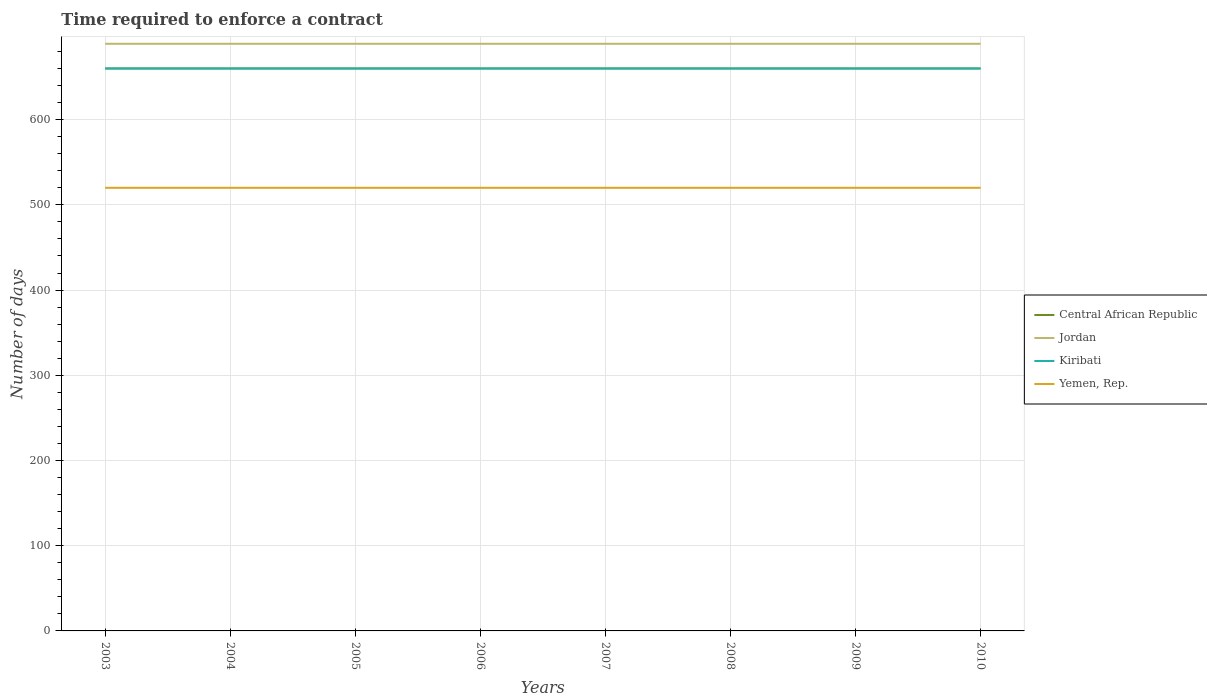Across all years, what is the maximum number of days required to enforce a contract in Kiribati?
Keep it short and to the point. 660. In which year was the number of days required to enforce a contract in Central African Republic maximum?
Provide a short and direct response. 2003. What is the total number of days required to enforce a contract in Yemen, Rep. in the graph?
Offer a terse response. 0. What is the difference between the highest and the lowest number of days required to enforce a contract in Yemen, Rep.?
Offer a terse response. 0. What is the difference between two consecutive major ticks on the Y-axis?
Offer a very short reply. 100. How many legend labels are there?
Your answer should be compact. 4. What is the title of the graph?
Your response must be concise. Time required to enforce a contract. What is the label or title of the X-axis?
Offer a very short reply. Years. What is the label or title of the Y-axis?
Provide a short and direct response. Number of days. What is the Number of days of Central African Republic in 2003?
Offer a terse response. 660. What is the Number of days of Jordan in 2003?
Make the answer very short. 689. What is the Number of days in Kiribati in 2003?
Your response must be concise. 660. What is the Number of days of Yemen, Rep. in 2003?
Provide a succinct answer. 520. What is the Number of days of Central African Republic in 2004?
Give a very brief answer. 660. What is the Number of days in Jordan in 2004?
Offer a terse response. 689. What is the Number of days in Kiribati in 2004?
Your answer should be compact. 660. What is the Number of days of Yemen, Rep. in 2004?
Keep it short and to the point. 520. What is the Number of days of Central African Republic in 2005?
Provide a succinct answer. 660. What is the Number of days in Jordan in 2005?
Provide a succinct answer. 689. What is the Number of days of Kiribati in 2005?
Provide a succinct answer. 660. What is the Number of days in Yemen, Rep. in 2005?
Your answer should be compact. 520. What is the Number of days in Central African Republic in 2006?
Keep it short and to the point. 660. What is the Number of days of Jordan in 2006?
Offer a terse response. 689. What is the Number of days of Kiribati in 2006?
Keep it short and to the point. 660. What is the Number of days of Yemen, Rep. in 2006?
Offer a very short reply. 520. What is the Number of days of Central African Republic in 2007?
Provide a short and direct response. 660. What is the Number of days in Jordan in 2007?
Provide a succinct answer. 689. What is the Number of days in Kiribati in 2007?
Your response must be concise. 660. What is the Number of days in Yemen, Rep. in 2007?
Give a very brief answer. 520. What is the Number of days of Central African Republic in 2008?
Ensure brevity in your answer.  660. What is the Number of days in Jordan in 2008?
Your answer should be very brief. 689. What is the Number of days in Kiribati in 2008?
Offer a very short reply. 660. What is the Number of days in Yemen, Rep. in 2008?
Provide a short and direct response. 520. What is the Number of days in Central African Republic in 2009?
Make the answer very short. 660. What is the Number of days of Jordan in 2009?
Offer a terse response. 689. What is the Number of days in Kiribati in 2009?
Keep it short and to the point. 660. What is the Number of days in Yemen, Rep. in 2009?
Your answer should be very brief. 520. What is the Number of days of Central African Republic in 2010?
Make the answer very short. 660. What is the Number of days of Jordan in 2010?
Keep it short and to the point. 689. What is the Number of days in Kiribati in 2010?
Provide a short and direct response. 660. What is the Number of days in Yemen, Rep. in 2010?
Ensure brevity in your answer.  520. Across all years, what is the maximum Number of days in Central African Republic?
Your response must be concise. 660. Across all years, what is the maximum Number of days of Jordan?
Ensure brevity in your answer.  689. Across all years, what is the maximum Number of days of Kiribati?
Provide a short and direct response. 660. Across all years, what is the maximum Number of days of Yemen, Rep.?
Your answer should be compact. 520. Across all years, what is the minimum Number of days in Central African Republic?
Keep it short and to the point. 660. Across all years, what is the minimum Number of days of Jordan?
Give a very brief answer. 689. Across all years, what is the minimum Number of days of Kiribati?
Your answer should be compact. 660. Across all years, what is the minimum Number of days in Yemen, Rep.?
Provide a succinct answer. 520. What is the total Number of days of Central African Republic in the graph?
Your answer should be very brief. 5280. What is the total Number of days in Jordan in the graph?
Your response must be concise. 5512. What is the total Number of days in Kiribati in the graph?
Ensure brevity in your answer.  5280. What is the total Number of days in Yemen, Rep. in the graph?
Offer a very short reply. 4160. What is the difference between the Number of days of Central African Republic in 2003 and that in 2004?
Give a very brief answer. 0. What is the difference between the Number of days in Jordan in 2003 and that in 2004?
Your answer should be very brief. 0. What is the difference between the Number of days in Kiribati in 2003 and that in 2004?
Keep it short and to the point. 0. What is the difference between the Number of days in Jordan in 2003 and that in 2005?
Offer a very short reply. 0. What is the difference between the Number of days in Central African Republic in 2003 and that in 2006?
Keep it short and to the point. 0. What is the difference between the Number of days in Kiribati in 2003 and that in 2006?
Your answer should be compact. 0. What is the difference between the Number of days in Jordan in 2003 and that in 2007?
Your answer should be compact. 0. What is the difference between the Number of days of Central African Republic in 2003 and that in 2008?
Ensure brevity in your answer.  0. What is the difference between the Number of days of Kiribati in 2003 and that in 2008?
Your response must be concise. 0. What is the difference between the Number of days in Yemen, Rep. in 2003 and that in 2008?
Provide a short and direct response. 0. What is the difference between the Number of days in Central African Republic in 2003 and that in 2009?
Provide a succinct answer. 0. What is the difference between the Number of days in Jordan in 2003 and that in 2009?
Provide a succinct answer. 0. What is the difference between the Number of days in Central African Republic in 2003 and that in 2010?
Ensure brevity in your answer.  0. What is the difference between the Number of days of Jordan in 2003 and that in 2010?
Provide a short and direct response. 0. What is the difference between the Number of days in Central African Republic in 2004 and that in 2005?
Provide a short and direct response. 0. What is the difference between the Number of days in Yemen, Rep. in 2004 and that in 2005?
Provide a short and direct response. 0. What is the difference between the Number of days of Kiribati in 2004 and that in 2007?
Offer a terse response. 0. What is the difference between the Number of days in Central African Republic in 2004 and that in 2008?
Provide a succinct answer. 0. What is the difference between the Number of days of Jordan in 2004 and that in 2008?
Keep it short and to the point. 0. What is the difference between the Number of days of Central African Republic in 2004 and that in 2009?
Offer a very short reply. 0. What is the difference between the Number of days of Jordan in 2004 and that in 2009?
Provide a short and direct response. 0. What is the difference between the Number of days of Kiribati in 2004 and that in 2009?
Ensure brevity in your answer.  0. What is the difference between the Number of days of Central African Republic in 2005 and that in 2006?
Give a very brief answer. 0. What is the difference between the Number of days of Jordan in 2005 and that in 2006?
Offer a very short reply. 0. What is the difference between the Number of days of Yemen, Rep. in 2005 and that in 2006?
Your response must be concise. 0. What is the difference between the Number of days in Jordan in 2005 and that in 2007?
Ensure brevity in your answer.  0. What is the difference between the Number of days in Kiribati in 2005 and that in 2008?
Offer a terse response. 0. What is the difference between the Number of days of Jordan in 2005 and that in 2009?
Offer a very short reply. 0. What is the difference between the Number of days in Kiribati in 2005 and that in 2009?
Ensure brevity in your answer.  0. What is the difference between the Number of days of Yemen, Rep. in 2005 and that in 2009?
Give a very brief answer. 0. What is the difference between the Number of days of Jordan in 2005 and that in 2010?
Your answer should be very brief. 0. What is the difference between the Number of days of Yemen, Rep. in 2006 and that in 2008?
Provide a succinct answer. 0. What is the difference between the Number of days in Central African Republic in 2006 and that in 2009?
Keep it short and to the point. 0. What is the difference between the Number of days in Jordan in 2006 and that in 2009?
Make the answer very short. 0. What is the difference between the Number of days in Kiribati in 2006 and that in 2009?
Give a very brief answer. 0. What is the difference between the Number of days of Jordan in 2006 and that in 2010?
Your answer should be compact. 0. What is the difference between the Number of days of Yemen, Rep. in 2006 and that in 2010?
Your answer should be very brief. 0. What is the difference between the Number of days of Central African Republic in 2007 and that in 2008?
Offer a terse response. 0. What is the difference between the Number of days of Jordan in 2007 and that in 2008?
Keep it short and to the point. 0. What is the difference between the Number of days in Jordan in 2007 and that in 2009?
Provide a short and direct response. 0. What is the difference between the Number of days of Kiribati in 2007 and that in 2009?
Keep it short and to the point. 0. What is the difference between the Number of days in Yemen, Rep. in 2007 and that in 2010?
Your answer should be compact. 0. What is the difference between the Number of days of Jordan in 2008 and that in 2009?
Provide a short and direct response. 0. What is the difference between the Number of days in Kiribati in 2008 and that in 2009?
Ensure brevity in your answer.  0. What is the difference between the Number of days in Yemen, Rep. in 2008 and that in 2010?
Keep it short and to the point. 0. What is the difference between the Number of days of Central African Republic in 2009 and that in 2010?
Provide a succinct answer. 0. What is the difference between the Number of days in Jordan in 2009 and that in 2010?
Provide a short and direct response. 0. What is the difference between the Number of days in Kiribati in 2009 and that in 2010?
Your answer should be compact. 0. What is the difference between the Number of days in Central African Republic in 2003 and the Number of days in Jordan in 2004?
Provide a short and direct response. -29. What is the difference between the Number of days in Central African Republic in 2003 and the Number of days in Yemen, Rep. in 2004?
Ensure brevity in your answer.  140. What is the difference between the Number of days of Jordan in 2003 and the Number of days of Kiribati in 2004?
Ensure brevity in your answer.  29. What is the difference between the Number of days of Jordan in 2003 and the Number of days of Yemen, Rep. in 2004?
Your answer should be very brief. 169. What is the difference between the Number of days in Kiribati in 2003 and the Number of days in Yemen, Rep. in 2004?
Keep it short and to the point. 140. What is the difference between the Number of days of Central African Republic in 2003 and the Number of days of Yemen, Rep. in 2005?
Provide a short and direct response. 140. What is the difference between the Number of days of Jordan in 2003 and the Number of days of Kiribati in 2005?
Provide a succinct answer. 29. What is the difference between the Number of days of Jordan in 2003 and the Number of days of Yemen, Rep. in 2005?
Offer a very short reply. 169. What is the difference between the Number of days in Kiribati in 2003 and the Number of days in Yemen, Rep. in 2005?
Offer a terse response. 140. What is the difference between the Number of days in Central African Republic in 2003 and the Number of days in Jordan in 2006?
Provide a succinct answer. -29. What is the difference between the Number of days in Central African Republic in 2003 and the Number of days in Yemen, Rep. in 2006?
Give a very brief answer. 140. What is the difference between the Number of days in Jordan in 2003 and the Number of days in Yemen, Rep. in 2006?
Keep it short and to the point. 169. What is the difference between the Number of days of Kiribati in 2003 and the Number of days of Yemen, Rep. in 2006?
Provide a short and direct response. 140. What is the difference between the Number of days of Central African Republic in 2003 and the Number of days of Kiribati in 2007?
Provide a short and direct response. 0. What is the difference between the Number of days of Central African Republic in 2003 and the Number of days of Yemen, Rep. in 2007?
Make the answer very short. 140. What is the difference between the Number of days in Jordan in 2003 and the Number of days in Kiribati in 2007?
Give a very brief answer. 29. What is the difference between the Number of days of Jordan in 2003 and the Number of days of Yemen, Rep. in 2007?
Provide a succinct answer. 169. What is the difference between the Number of days in Kiribati in 2003 and the Number of days in Yemen, Rep. in 2007?
Your answer should be very brief. 140. What is the difference between the Number of days in Central African Republic in 2003 and the Number of days in Yemen, Rep. in 2008?
Your response must be concise. 140. What is the difference between the Number of days of Jordan in 2003 and the Number of days of Kiribati in 2008?
Provide a succinct answer. 29. What is the difference between the Number of days in Jordan in 2003 and the Number of days in Yemen, Rep. in 2008?
Your answer should be very brief. 169. What is the difference between the Number of days of Kiribati in 2003 and the Number of days of Yemen, Rep. in 2008?
Make the answer very short. 140. What is the difference between the Number of days of Central African Republic in 2003 and the Number of days of Jordan in 2009?
Keep it short and to the point. -29. What is the difference between the Number of days of Central African Republic in 2003 and the Number of days of Kiribati in 2009?
Your response must be concise. 0. What is the difference between the Number of days of Central African Republic in 2003 and the Number of days of Yemen, Rep. in 2009?
Offer a terse response. 140. What is the difference between the Number of days of Jordan in 2003 and the Number of days of Yemen, Rep. in 2009?
Provide a short and direct response. 169. What is the difference between the Number of days of Kiribati in 2003 and the Number of days of Yemen, Rep. in 2009?
Provide a short and direct response. 140. What is the difference between the Number of days of Central African Republic in 2003 and the Number of days of Yemen, Rep. in 2010?
Provide a succinct answer. 140. What is the difference between the Number of days of Jordan in 2003 and the Number of days of Yemen, Rep. in 2010?
Your answer should be compact. 169. What is the difference between the Number of days of Kiribati in 2003 and the Number of days of Yemen, Rep. in 2010?
Offer a terse response. 140. What is the difference between the Number of days in Central African Republic in 2004 and the Number of days in Yemen, Rep. in 2005?
Offer a terse response. 140. What is the difference between the Number of days of Jordan in 2004 and the Number of days of Kiribati in 2005?
Keep it short and to the point. 29. What is the difference between the Number of days in Jordan in 2004 and the Number of days in Yemen, Rep. in 2005?
Offer a very short reply. 169. What is the difference between the Number of days of Kiribati in 2004 and the Number of days of Yemen, Rep. in 2005?
Offer a terse response. 140. What is the difference between the Number of days of Central African Republic in 2004 and the Number of days of Yemen, Rep. in 2006?
Your answer should be very brief. 140. What is the difference between the Number of days of Jordan in 2004 and the Number of days of Yemen, Rep. in 2006?
Your answer should be very brief. 169. What is the difference between the Number of days of Kiribati in 2004 and the Number of days of Yemen, Rep. in 2006?
Give a very brief answer. 140. What is the difference between the Number of days in Central African Republic in 2004 and the Number of days in Yemen, Rep. in 2007?
Your answer should be very brief. 140. What is the difference between the Number of days in Jordan in 2004 and the Number of days in Kiribati in 2007?
Your response must be concise. 29. What is the difference between the Number of days in Jordan in 2004 and the Number of days in Yemen, Rep. in 2007?
Keep it short and to the point. 169. What is the difference between the Number of days of Kiribati in 2004 and the Number of days of Yemen, Rep. in 2007?
Your answer should be very brief. 140. What is the difference between the Number of days of Central African Republic in 2004 and the Number of days of Yemen, Rep. in 2008?
Provide a short and direct response. 140. What is the difference between the Number of days in Jordan in 2004 and the Number of days in Yemen, Rep. in 2008?
Ensure brevity in your answer.  169. What is the difference between the Number of days in Kiribati in 2004 and the Number of days in Yemen, Rep. in 2008?
Offer a very short reply. 140. What is the difference between the Number of days of Central African Republic in 2004 and the Number of days of Jordan in 2009?
Your response must be concise. -29. What is the difference between the Number of days of Central African Republic in 2004 and the Number of days of Yemen, Rep. in 2009?
Ensure brevity in your answer.  140. What is the difference between the Number of days of Jordan in 2004 and the Number of days of Kiribati in 2009?
Provide a succinct answer. 29. What is the difference between the Number of days in Jordan in 2004 and the Number of days in Yemen, Rep. in 2009?
Make the answer very short. 169. What is the difference between the Number of days in Kiribati in 2004 and the Number of days in Yemen, Rep. in 2009?
Make the answer very short. 140. What is the difference between the Number of days in Central African Republic in 2004 and the Number of days in Yemen, Rep. in 2010?
Provide a short and direct response. 140. What is the difference between the Number of days in Jordan in 2004 and the Number of days in Yemen, Rep. in 2010?
Your answer should be very brief. 169. What is the difference between the Number of days in Kiribati in 2004 and the Number of days in Yemen, Rep. in 2010?
Your answer should be compact. 140. What is the difference between the Number of days of Central African Republic in 2005 and the Number of days of Yemen, Rep. in 2006?
Your response must be concise. 140. What is the difference between the Number of days of Jordan in 2005 and the Number of days of Yemen, Rep. in 2006?
Provide a short and direct response. 169. What is the difference between the Number of days in Kiribati in 2005 and the Number of days in Yemen, Rep. in 2006?
Your answer should be very brief. 140. What is the difference between the Number of days of Central African Republic in 2005 and the Number of days of Kiribati in 2007?
Your answer should be very brief. 0. What is the difference between the Number of days of Central African Republic in 2005 and the Number of days of Yemen, Rep. in 2007?
Keep it short and to the point. 140. What is the difference between the Number of days of Jordan in 2005 and the Number of days of Yemen, Rep. in 2007?
Your response must be concise. 169. What is the difference between the Number of days in Kiribati in 2005 and the Number of days in Yemen, Rep. in 2007?
Your answer should be very brief. 140. What is the difference between the Number of days of Central African Republic in 2005 and the Number of days of Kiribati in 2008?
Your response must be concise. 0. What is the difference between the Number of days in Central African Republic in 2005 and the Number of days in Yemen, Rep. in 2008?
Your response must be concise. 140. What is the difference between the Number of days in Jordan in 2005 and the Number of days in Yemen, Rep. in 2008?
Your response must be concise. 169. What is the difference between the Number of days in Kiribati in 2005 and the Number of days in Yemen, Rep. in 2008?
Keep it short and to the point. 140. What is the difference between the Number of days of Central African Republic in 2005 and the Number of days of Jordan in 2009?
Your answer should be very brief. -29. What is the difference between the Number of days of Central African Republic in 2005 and the Number of days of Kiribati in 2009?
Your answer should be very brief. 0. What is the difference between the Number of days of Central African Republic in 2005 and the Number of days of Yemen, Rep. in 2009?
Give a very brief answer. 140. What is the difference between the Number of days of Jordan in 2005 and the Number of days of Kiribati in 2009?
Provide a succinct answer. 29. What is the difference between the Number of days of Jordan in 2005 and the Number of days of Yemen, Rep. in 2009?
Keep it short and to the point. 169. What is the difference between the Number of days in Kiribati in 2005 and the Number of days in Yemen, Rep. in 2009?
Your answer should be very brief. 140. What is the difference between the Number of days in Central African Republic in 2005 and the Number of days in Kiribati in 2010?
Your answer should be compact. 0. What is the difference between the Number of days of Central African Republic in 2005 and the Number of days of Yemen, Rep. in 2010?
Keep it short and to the point. 140. What is the difference between the Number of days in Jordan in 2005 and the Number of days in Yemen, Rep. in 2010?
Offer a very short reply. 169. What is the difference between the Number of days in Kiribati in 2005 and the Number of days in Yemen, Rep. in 2010?
Give a very brief answer. 140. What is the difference between the Number of days of Central African Republic in 2006 and the Number of days of Jordan in 2007?
Provide a succinct answer. -29. What is the difference between the Number of days of Central African Republic in 2006 and the Number of days of Yemen, Rep. in 2007?
Provide a short and direct response. 140. What is the difference between the Number of days of Jordan in 2006 and the Number of days of Kiribati in 2007?
Offer a very short reply. 29. What is the difference between the Number of days in Jordan in 2006 and the Number of days in Yemen, Rep. in 2007?
Your answer should be very brief. 169. What is the difference between the Number of days in Kiribati in 2006 and the Number of days in Yemen, Rep. in 2007?
Your answer should be compact. 140. What is the difference between the Number of days of Central African Republic in 2006 and the Number of days of Yemen, Rep. in 2008?
Your answer should be compact. 140. What is the difference between the Number of days of Jordan in 2006 and the Number of days of Yemen, Rep. in 2008?
Your answer should be compact. 169. What is the difference between the Number of days of Kiribati in 2006 and the Number of days of Yemen, Rep. in 2008?
Offer a very short reply. 140. What is the difference between the Number of days of Central African Republic in 2006 and the Number of days of Yemen, Rep. in 2009?
Offer a terse response. 140. What is the difference between the Number of days in Jordan in 2006 and the Number of days in Kiribati in 2009?
Give a very brief answer. 29. What is the difference between the Number of days in Jordan in 2006 and the Number of days in Yemen, Rep. in 2009?
Offer a terse response. 169. What is the difference between the Number of days in Kiribati in 2006 and the Number of days in Yemen, Rep. in 2009?
Offer a terse response. 140. What is the difference between the Number of days in Central African Republic in 2006 and the Number of days in Jordan in 2010?
Provide a succinct answer. -29. What is the difference between the Number of days in Central African Republic in 2006 and the Number of days in Kiribati in 2010?
Your answer should be compact. 0. What is the difference between the Number of days in Central African Republic in 2006 and the Number of days in Yemen, Rep. in 2010?
Ensure brevity in your answer.  140. What is the difference between the Number of days in Jordan in 2006 and the Number of days in Yemen, Rep. in 2010?
Offer a terse response. 169. What is the difference between the Number of days of Kiribati in 2006 and the Number of days of Yemen, Rep. in 2010?
Make the answer very short. 140. What is the difference between the Number of days in Central African Republic in 2007 and the Number of days in Jordan in 2008?
Your response must be concise. -29. What is the difference between the Number of days of Central African Republic in 2007 and the Number of days of Yemen, Rep. in 2008?
Offer a very short reply. 140. What is the difference between the Number of days of Jordan in 2007 and the Number of days of Kiribati in 2008?
Provide a succinct answer. 29. What is the difference between the Number of days of Jordan in 2007 and the Number of days of Yemen, Rep. in 2008?
Provide a short and direct response. 169. What is the difference between the Number of days in Kiribati in 2007 and the Number of days in Yemen, Rep. in 2008?
Provide a short and direct response. 140. What is the difference between the Number of days of Central African Republic in 2007 and the Number of days of Jordan in 2009?
Ensure brevity in your answer.  -29. What is the difference between the Number of days of Central African Republic in 2007 and the Number of days of Kiribati in 2009?
Your response must be concise. 0. What is the difference between the Number of days of Central African Republic in 2007 and the Number of days of Yemen, Rep. in 2009?
Ensure brevity in your answer.  140. What is the difference between the Number of days in Jordan in 2007 and the Number of days in Yemen, Rep. in 2009?
Your response must be concise. 169. What is the difference between the Number of days of Kiribati in 2007 and the Number of days of Yemen, Rep. in 2009?
Keep it short and to the point. 140. What is the difference between the Number of days in Central African Republic in 2007 and the Number of days in Kiribati in 2010?
Your response must be concise. 0. What is the difference between the Number of days of Central African Republic in 2007 and the Number of days of Yemen, Rep. in 2010?
Offer a very short reply. 140. What is the difference between the Number of days of Jordan in 2007 and the Number of days of Kiribati in 2010?
Offer a terse response. 29. What is the difference between the Number of days in Jordan in 2007 and the Number of days in Yemen, Rep. in 2010?
Your answer should be very brief. 169. What is the difference between the Number of days of Kiribati in 2007 and the Number of days of Yemen, Rep. in 2010?
Your response must be concise. 140. What is the difference between the Number of days in Central African Republic in 2008 and the Number of days in Jordan in 2009?
Provide a succinct answer. -29. What is the difference between the Number of days in Central African Republic in 2008 and the Number of days in Kiribati in 2009?
Your answer should be very brief. 0. What is the difference between the Number of days in Central African Republic in 2008 and the Number of days in Yemen, Rep. in 2009?
Provide a succinct answer. 140. What is the difference between the Number of days of Jordan in 2008 and the Number of days of Kiribati in 2009?
Provide a succinct answer. 29. What is the difference between the Number of days of Jordan in 2008 and the Number of days of Yemen, Rep. in 2009?
Your answer should be very brief. 169. What is the difference between the Number of days of Kiribati in 2008 and the Number of days of Yemen, Rep. in 2009?
Offer a very short reply. 140. What is the difference between the Number of days of Central African Republic in 2008 and the Number of days of Jordan in 2010?
Provide a succinct answer. -29. What is the difference between the Number of days in Central African Republic in 2008 and the Number of days in Kiribati in 2010?
Your answer should be compact. 0. What is the difference between the Number of days of Central African Republic in 2008 and the Number of days of Yemen, Rep. in 2010?
Your response must be concise. 140. What is the difference between the Number of days in Jordan in 2008 and the Number of days in Kiribati in 2010?
Provide a short and direct response. 29. What is the difference between the Number of days in Jordan in 2008 and the Number of days in Yemen, Rep. in 2010?
Your answer should be compact. 169. What is the difference between the Number of days in Kiribati in 2008 and the Number of days in Yemen, Rep. in 2010?
Offer a terse response. 140. What is the difference between the Number of days in Central African Republic in 2009 and the Number of days in Yemen, Rep. in 2010?
Keep it short and to the point. 140. What is the difference between the Number of days in Jordan in 2009 and the Number of days in Yemen, Rep. in 2010?
Your answer should be very brief. 169. What is the difference between the Number of days in Kiribati in 2009 and the Number of days in Yemen, Rep. in 2010?
Keep it short and to the point. 140. What is the average Number of days of Central African Republic per year?
Your answer should be compact. 660. What is the average Number of days in Jordan per year?
Make the answer very short. 689. What is the average Number of days in Kiribati per year?
Your answer should be very brief. 660. What is the average Number of days of Yemen, Rep. per year?
Your response must be concise. 520. In the year 2003, what is the difference between the Number of days of Central African Republic and Number of days of Jordan?
Ensure brevity in your answer.  -29. In the year 2003, what is the difference between the Number of days of Central African Republic and Number of days of Kiribati?
Provide a succinct answer. 0. In the year 2003, what is the difference between the Number of days in Central African Republic and Number of days in Yemen, Rep.?
Your response must be concise. 140. In the year 2003, what is the difference between the Number of days in Jordan and Number of days in Yemen, Rep.?
Provide a succinct answer. 169. In the year 2003, what is the difference between the Number of days of Kiribati and Number of days of Yemen, Rep.?
Provide a short and direct response. 140. In the year 2004, what is the difference between the Number of days of Central African Republic and Number of days of Jordan?
Ensure brevity in your answer.  -29. In the year 2004, what is the difference between the Number of days in Central African Republic and Number of days in Yemen, Rep.?
Keep it short and to the point. 140. In the year 2004, what is the difference between the Number of days of Jordan and Number of days of Yemen, Rep.?
Offer a terse response. 169. In the year 2004, what is the difference between the Number of days of Kiribati and Number of days of Yemen, Rep.?
Give a very brief answer. 140. In the year 2005, what is the difference between the Number of days of Central African Republic and Number of days of Jordan?
Your answer should be very brief. -29. In the year 2005, what is the difference between the Number of days in Central African Republic and Number of days in Kiribati?
Your response must be concise. 0. In the year 2005, what is the difference between the Number of days of Central African Republic and Number of days of Yemen, Rep.?
Ensure brevity in your answer.  140. In the year 2005, what is the difference between the Number of days in Jordan and Number of days in Yemen, Rep.?
Ensure brevity in your answer.  169. In the year 2005, what is the difference between the Number of days in Kiribati and Number of days in Yemen, Rep.?
Keep it short and to the point. 140. In the year 2006, what is the difference between the Number of days of Central African Republic and Number of days of Yemen, Rep.?
Give a very brief answer. 140. In the year 2006, what is the difference between the Number of days in Jordan and Number of days in Yemen, Rep.?
Your response must be concise. 169. In the year 2006, what is the difference between the Number of days of Kiribati and Number of days of Yemen, Rep.?
Provide a succinct answer. 140. In the year 2007, what is the difference between the Number of days of Central African Republic and Number of days of Kiribati?
Give a very brief answer. 0. In the year 2007, what is the difference between the Number of days of Central African Republic and Number of days of Yemen, Rep.?
Your answer should be compact. 140. In the year 2007, what is the difference between the Number of days in Jordan and Number of days in Yemen, Rep.?
Your response must be concise. 169. In the year 2007, what is the difference between the Number of days of Kiribati and Number of days of Yemen, Rep.?
Provide a short and direct response. 140. In the year 2008, what is the difference between the Number of days in Central African Republic and Number of days in Yemen, Rep.?
Keep it short and to the point. 140. In the year 2008, what is the difference between the Number of days of Jordan and Number of days of Kiribati?
Your answer should be very brief. 29. In the year 2008, what is the difference between the Number of days of Jordan and Number of days of Yemen, Rep.?
Make the answer very short. 169. In the year 2008, what is the difference between the Number of days of Kiribati and Number of days of Yemen, Rep.?
Give a very brief answer. 140. In the year 2009, what is the difference between the Number of days in Central African Republic and Number of days in Jordan?
Your response must be concise. -29. In the year 2009, what is the difference between the Number of days of Central African Republic and Number of days of Kiribati?
Your answer should be compact. 0. In the year 2009, what is the difference between the Number of days of Central African Republic and Number of days of Yemen, Rep.?
Keep it short and to the point. 140. In the year 2009, what is the difference between the Number of days of Jordan and Number of days of Kiribati?
Ensure brevity in your answer.  29. In the year 2009, what is the difference between the Number of days of Jordan and Number of days of Yemen, Rep.?
Your response must be concise. 169. In the year 2009, what is the difference between the Number of days of Kiribati and Number of days of Yemen, Rep.?
Your answer should be compact. 140. In the year 2010, what is the difference between the Number of days of Central African Republic and Number of days of Kiribati?
Provide a short and direct response. 0. In the year 2010, what is the difference between the Number of days in Central African Republic and Number of days in Yemen, Rep.?
Offer a very short reply. 140. In the year 2010, what is the difference between the Number of days in Jordan and Number of days in Yemen, Rep.?
Provide a succinct answer. 169. In the year 2010, what is the difference between the Number of days of Kiribati and Number of days of Yemen, Rep.?
Your response must be concise. 140. What is the ratio of the Number of days in Central African Republic in 2003 to that in 2004?
Offer a terse response. 1. What is the ratio of the Number of days in Jordan in 2003 to that in 2004?
Make the answer very short. 1. What is the ratio of the Number of days of Central African Republic in 2003 to that in 2005?
Provide a succinct answer. 1. What is the ratio of the Number of days of Yemen, Rep. in 2003 to that in 2005?
Ensure brevity in your answer.  1. What is the ratio of the Number of days of Yemen, Rep. in 2003 to that in 2006?
Offer a very short reply. 1. What is the ratio of the Number of days in Central African Republic in 2003 to that in 2008?
Your answer should be very brief. 1. What is the ratio of the Number of days in Jordan in 2003 to that in 2008?
Your response must be concise. 1. What is the ratio of the Number of days in Yemen, Rep. in 2003 to that in 2008?
Ensure brevity in your answer.  1. What is the ratio of the Number of days in Yemen, Rep. in 2003 to that in 2009?
Offer a terse response. 1. What is the ratio of the Number of days in Kiribati in 2003 to that in 2010?
Provide a short and direct response. 1. What is the ratio of the Number of days in Yemen, Rep. in 2003 to that in 2010?
Your response must be concise. 1. What is the ratio of the Number of days of Kiribati in 2004 to that in 2005?
Your answer should be very brief. 1. What is the ratio of the Number of days of Yemen, Rep. in 2004 to that in 2005?
Provide a short and direct response. 1. What is the ratio of the Number of days of Jordan in 2004 to that in 2007?
Your answer should be very brief. 1. What is the ratio of the Number of days in Yemen, Rep. in 2004 to that in 2007?
Keep it short and to the point. 1. What is the ratio of the Number of days of Central African Republic in 2004 to that in 2008?
Offer a terse response. 1. What is the ratio of the Number of days of Jordan in 2004 to that in 2008?
Provide a succinct answer. 1. What is the ratio of the Number of days in Kiribati in 2004 to that in 2008?
Offer a very short reply. 1. What is the ratio of the Number of days of Yemen, Rep. in 2004 to that in 2008?
Make the answer very short. 1. What is the ratio of the Number of days in Central African Republic in 2004 to that in 2009?
Provide a succinct answer. 1. What is the ratio of the Number of days of Jordan in 2004 to that in 2009?
Ensure brevity in your answer.  1. What is the ratio of the Number of days in Kiribati in 2004 to that in 2009?
Give a very brief answer. 1. What is the ratio of the Number of days of Jordan in 2004 to that in 2010?
Make the answer very short. 1. What is the ratio of the Number of days of Central African Republic in 2005 to that in 2006?
Give a very brief answer. 1. What is the ratio of the Number of days of Jordan in 2005 to that in 2006?
Keep it short and to the point. 1. What is the ratio of the Number of days in Kiribati in 2005 to that in 2006?
Offer a terse response. 1. What is the ratio of the Number of days in Yemen, Rep. in 2005 to that in 2006?
Offer a terse response. 1. What is the ratio of the Number of days in Yemen, Rep. in 2005 to that in 2007?
Provide a short and direct response. 1. What is the ratio of the Number of days in Central African Republic in 2005 to that in 2008?
Keep it short and to the point. 1. What is the ratio of the Number of days in Jordan in 2005 to that in 2008?
Your response must be concise. 1. What is the ratio of the Number of days in Yemen, Rep. in 2005 to that in 2008?
Give a very brief answer. 1. What is the ratio of the Number of days of Kiribati in 2005 to that in 2009?
Offer a very short reply. 1. What is the ratio of the Number of days in Yemen, Rep. in 2005 to that in 2009?
Make the answer very short. 1. What is the ratio of the Number of days of Jordan in 2005 to that in 2010?
Keep it short and to the point. 1. What is the ratio of the Number of days of Kiribati in 2005 to that in 2010?
Your answer should be compact. 1. What is the ratio of the Number of days in Jordan in 2006 to that in 2007?
Ensure brevity in your answer.  1. What is the ratio of the Number of days in Kiribati in 2006 to that in 2007?
Provide a short and direct response. 1. What is the ratio of the Number of days in Central African Republic in 2006 to that in 2008?
Provide a succinct answer. 1. What is the ratio of the Number of days of Kiribati in 2006 to that in 2008?
Provide a succinct answer. 1. What is the ratio of the Number of days in Central African Republic in 2006 to that in 2009?
Your response must be concise. 1. What is the ratio of the Number of days in Central African Republic in 2007 to that in 2008?
Offer a terse response. 1. What is the ratio of the Number of days in Central African Republic in 2007 to that in 2010?
Offer a terse response. 1. What is the ratio of the Number of days in Yemen, Rep. in 2007 to that in 2010?
Give a very brief answer. 1. What is the ratio of the Number of days of Central African Republic in 2008 to that in 2009?
Offer a terse response. 1. What is the ratio of the Number of days in Jordan in 2008 to that in 2009?
Ensure brevity in your answer.  1. What is the ratio of the Number of days of Kiribati in 2008 to that in 2009?
Provide a succinct answer. 1. What is the ratio of the Number of days in Jordan in 2008 to that in 2010?
Provide a short and direct response. 1. What is the ratio of the Number of days of Kiribati in 2008 to that in 2010?
Ensure brevity in your answer.  1. What is the ratio of the Number of days in Yemen, Rep. in 2008 to that in 2010?
Provide a short and direct response. 1. What is the ratio of the Number of days in Central African Republic in 2009 to that in 2010?
Provide a succinct answer. 1. What is the ratio of the Number of days in Kiribati in 2009 to that in 2010?
Provide a succinct answer. 1. What is the difference between the highest and the second highest Number of days of Jordan?
Offer a very short reply. 0. What is the difference between the highest and the second highest Number of days of Yemen, Rep.?
Make the answer very short. 0. What is the difference between the highest and the lowest Number of days of Yemen, Rep.?
Your response must be concise. 0. 